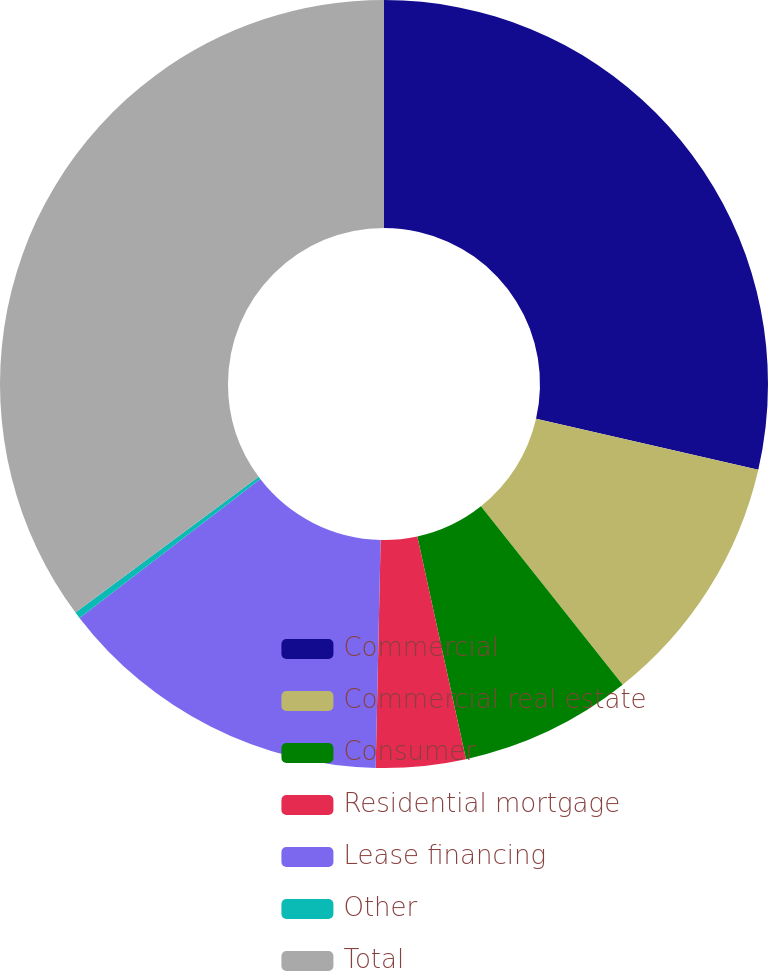Convert chart to OTSL. <chart><loc_0><loc_0><loc_500><loc_500><pie_chart><fcel>Commercial<fcel>Commercial real estate<fcel>Consumer<fcel>Residential mortgage<fcel>Lease financing<fcel>Other<fcel>Total<nl><fcel>28.59%<fcel>10.74%<fcel>7.25%<fcel>3.77%<fcel>14.23%<fcel>0.28%<fcel>35.15%<nl></chart> 